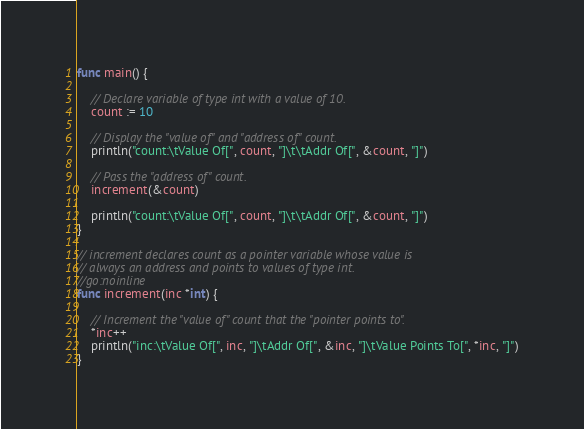Convert code to text. <code><loc_0><loc_0><loc_500><loc_500><_Go_>func main() {

	// Declare variable of type int with a value of 10.
	count := 10

	// Display the "value of" and "address of" count.
	println("count:\tValue Of[", count, "]\t\tAddr Of[", &count, "]")

	// Pass the "address of" count.
	increment(&count)

	println("count:\tValue Of[", count, "]\t\tAddr Of[", &count, "]")
}

// increment declares count as a pointer variable whose value is
// always an address and points to values of type int.
//go:noinline
func increment(inc *int) {

	// Increment the "value of" count that the "pointer points to".
	*inc++
	println("inc:\tValue Of[", inc, "]\tAddr Of[", &inc, "]\tValue Points To[", *inc, "]")
}
</code> 